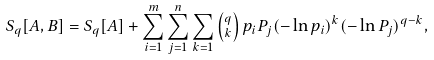Convert formula to latex. <formula><loc_0><loc_0><loc_500><loc_500>S _ { q } [ A , B ] = S _ { q } [ A ] + \sum _ { i = 1 } ^ { m } \sum _ { j = 1 } ^ { n } \sum _ { k = 1 } \left ( _ { k } ^ { q } \right ) p _ { i } P _ { j } ( - \ln p _ { i } ) ^ { k } ( - \ln P _ { j } ) ^ { q - k } ,</formula> 